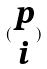<formula> <loc_0><loc_0><loc_500><loc_500>( \begin{matrix} p \\ i \end{matrix} )</formula> 